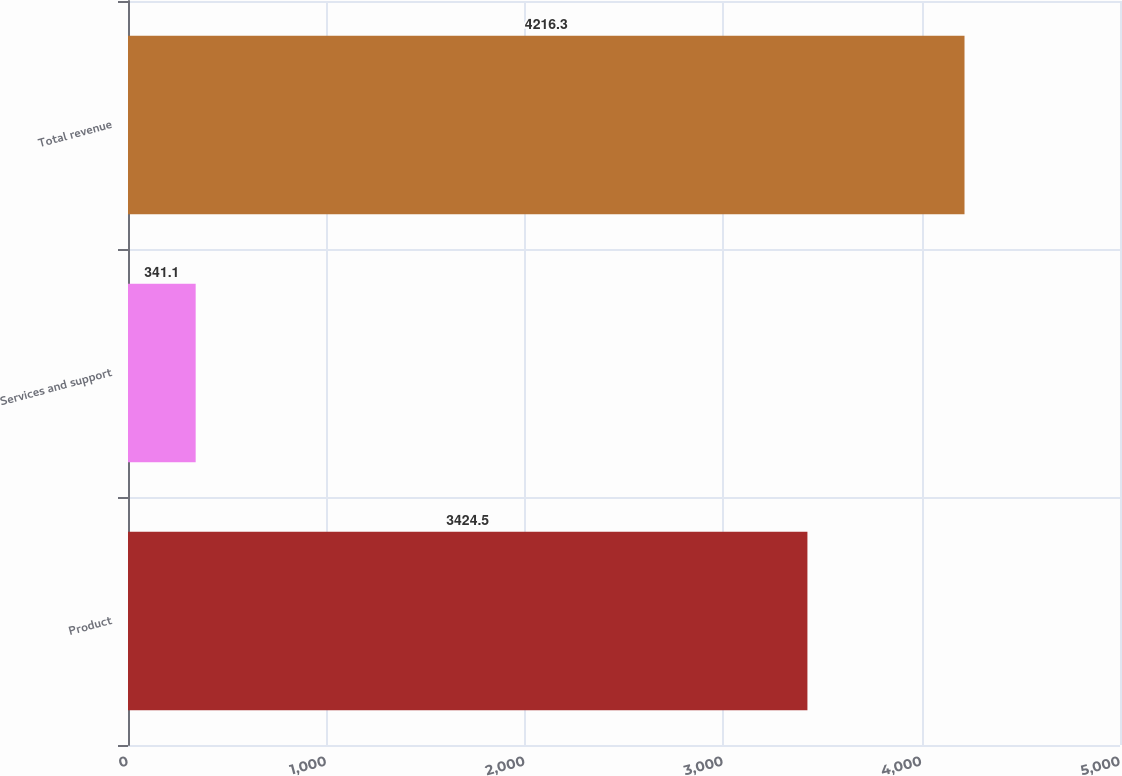Convert chart to OTSL. <chart><loc_0><loc_0><loc_500><loc_500><bar_chart><fcel>Product<fcel>Services and support<fcel>Total revenue<nl><fcel>3424.5<fcel>341.1<fcel>4216.3<nl></chart> 